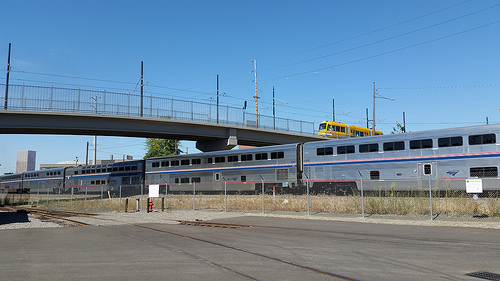<image>
Is the train in front of the bus? Yes. The train is positioned in front of the bus, appearing closer to the camera viewpoint. 